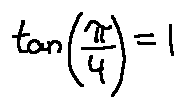<formula> <loc_0><loc_0><loc_500><loc_500>\tan ( \frac { \pi } { 4 } ) = 1</formula> 